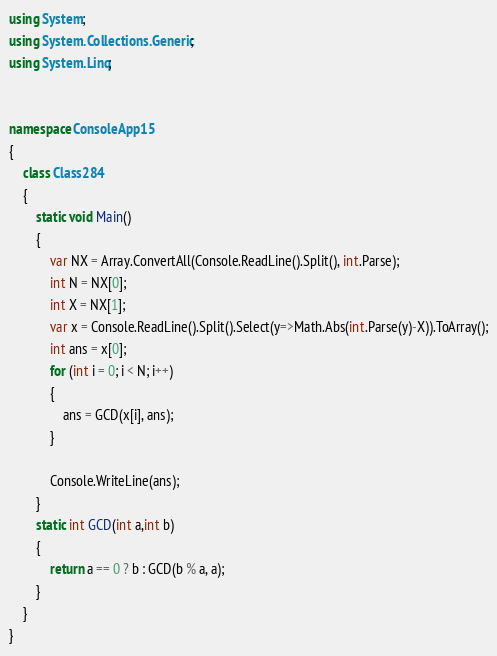Convert code to text. <code><loc_0><loc_0><loc_500><loc_500><_C#_>using System;
using System.Collections.Generic;
using System.Linq;


namespace ConsoleApp15
{
    class Class284
    {
        static void Main()
        {
            var NX = Array.ConvertAll(Console.ReadLine().Split(), int.Parse);
            int N = NX[0];
            int X = NX[1];
            var x = Console.ReadLine().Split().Select(y=>Math.Abs(int.Parse(y)-X)).ToArray();
            int ans = x[0];
            for (int i = 0; i < N; i++)
            {
                ans = GCD(x[i], ans);
            }

            Console.WriteLine(ans);
        }
        static int GCD(int a,int b)
        {
            return a == 0 ? b : GCD(b % a, a);
        }
    }
}
</code> 